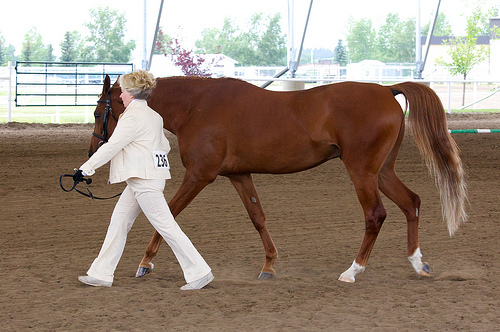<image>
Is there a woman to the left of the flowering tree? Yes. From this viewpoint, the woman is positioned to the left side relative to the flowering tree. 